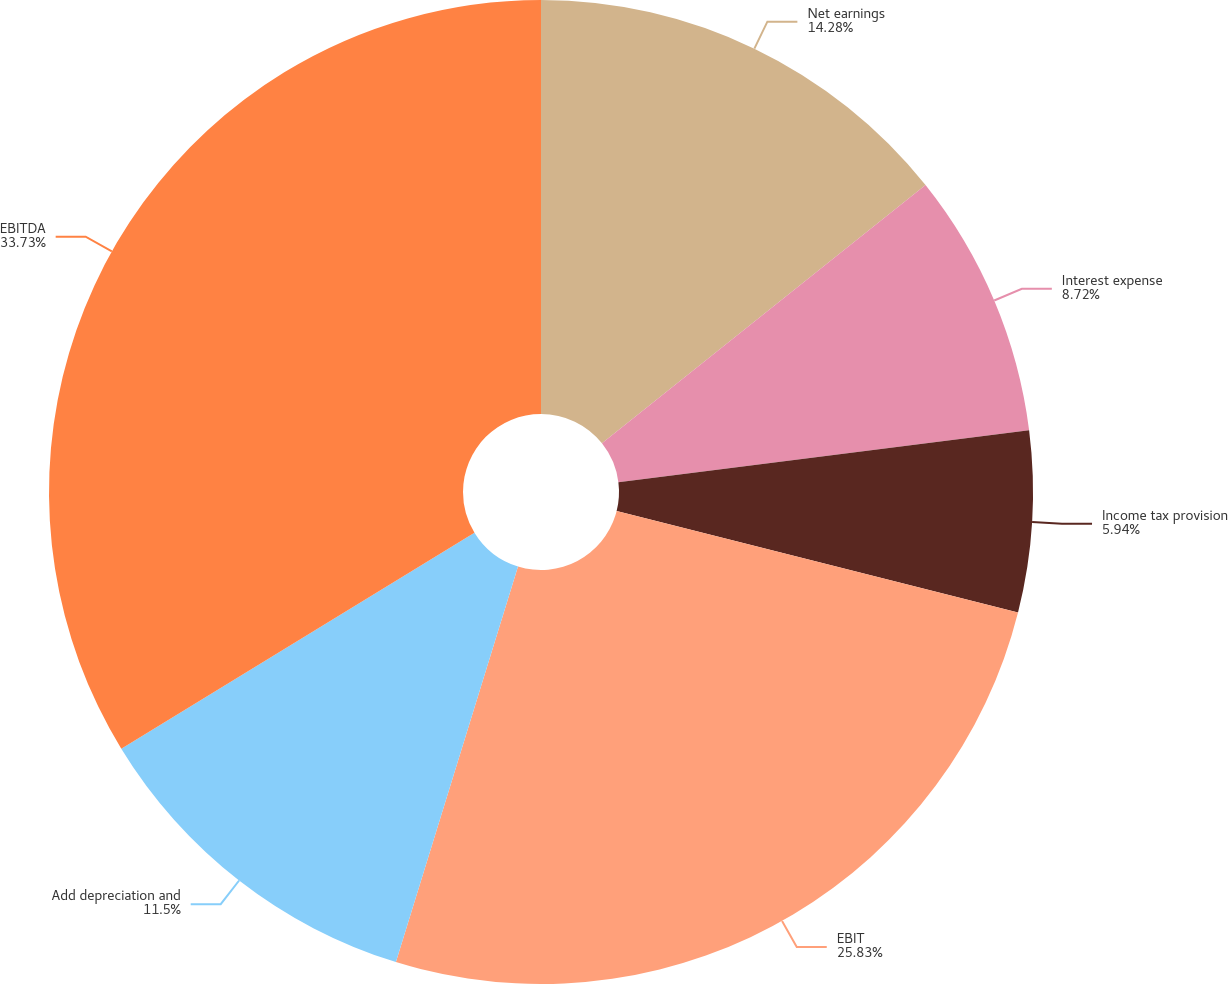Convert chart. <chart><loc_0><loc_0><loc_500><loc_500><pie_chart><fcel>Net earnings<fcel>Interest expense<fcel>Income tax provision<fcel>EBIT<fcel>Add depreciation and<fcel>EBITDA<nl><fcel>14.28%<fcel>8.72%<fcel>5.94%<fcel>25.83%<fcel>11.5%<fcel>33.74%<nl></chart> 